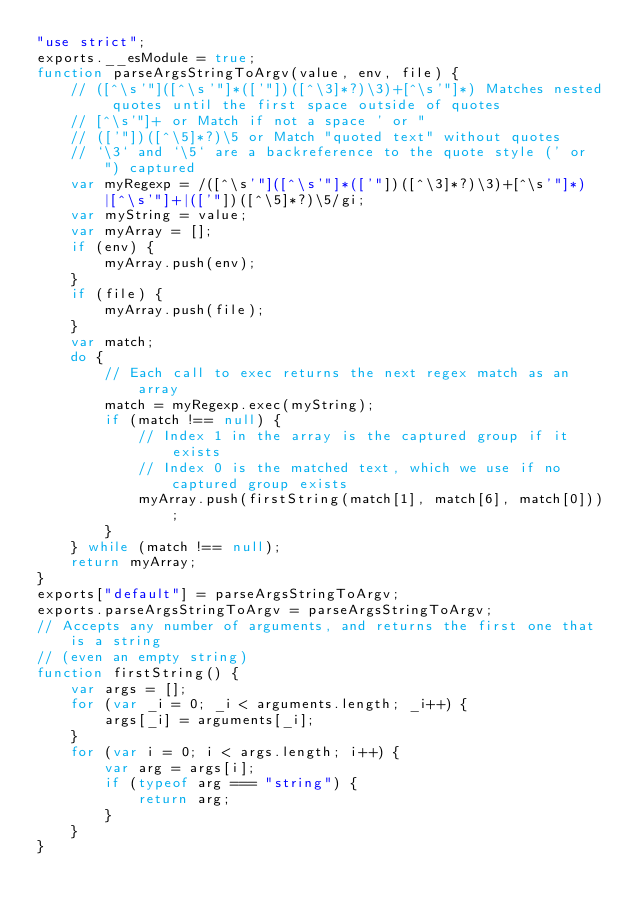Convert code to text. <code><loc_0><loc_0><loc_500><loc_500><_JavaScript_>"use strict";
exports.__esModule = true;
function parseArgsStringToArgv(value, env, file) {
    // ([^\s'"]([^\s'"]*(['"])([^\3]*?)\3)+[^\s'"]*) Matches nested quotes until the first space outside of quotes
    // [^\s'"]+ or Match if not a space ' or "
    // (['"])([^\5]*?)\5 or Match "quoted text" without quotes
    // `\3` and `\5` are a backreference to the quote style (' or ") captured
    var myRegexp = /([^\s'"]([^\s'"]*(['"])([^\3]*?)\3)+[^\s'"]*)|[^\s'"]+|(['"])([^\5]*?)\5/gi;
    var myString = value;
    var myArray = [];
    if (env) {
        myArray.push(env);
    }
    if (file) {
        myArray.push(file);
    }
    var match;
    do {
        // Each call to exec returns the next regex match as an array
        match = myRegexp.exec(myString);
        if (match !== null) {
            // Index 1 in the array is the captured group if it exists
            // Index 0 is the matched text, which we use if no captured group exists
            myArray.push(firstString(match[1], match[6], match[0]));
        }
    } while (match !== null);
    return myArray;
}
exports["default"] = parseArgsStringToArgv;
exports.parseArgsStringToArgv = parseArgsStringToArgv;
// Accepts any number of arguments, and returns the first one that is a string
// (even an empty string)
function firstString() {
    var args = [];
    for (var _i = 0; _i < arguments.length; _i++) {
        args[_i] = arguments[_i];
    }
    for (var i = 0; i < args.length; i++) {
        var arg = args[i];
        if (typeof arg === "string") {
            return arg;
        }
    }
}
</code> 